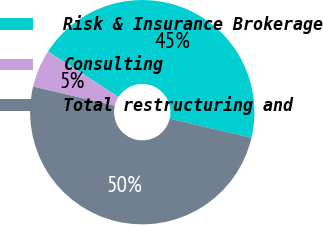Convert chart to OTSL. <chart><loc_0><loc_0><loc_500><loc_500><pie_chart><fcel>Risk & Insurance Brokerage<fcel>Consulting<fcel>Total restructuring and<nl><fcel>44.57%<fcel>5.43%<fcel>50.0%<nl></chart> 